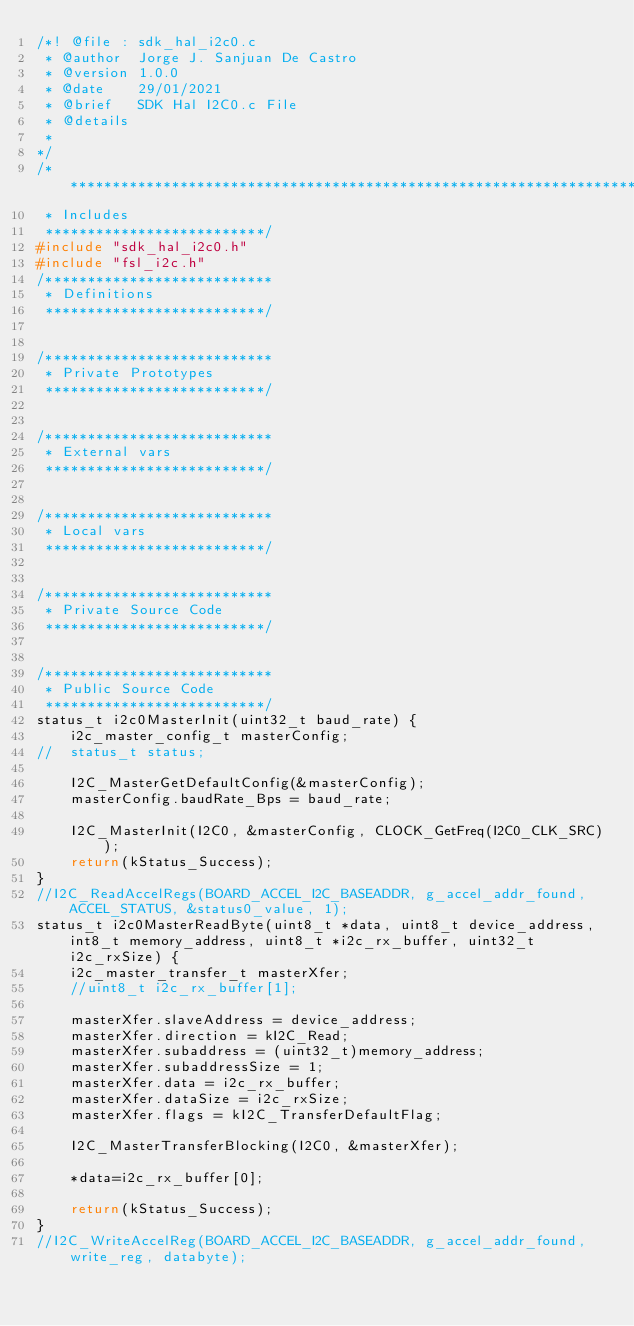<code> <loc_0><loc_0><loc_500><loc_500><_C_>/*! @file : sdk_hal_i2c0.c
 * @author  Jorge J. Sanjuan De Castro
 * @version 1.0.0
 * @date    29/01/2021
 * @brief   SDK Hal I2C0.c File
 * @details
 *
*/
/*******************************************************************************
 * Includes
 **************************/
#include "sdk_hal_i2c0.h"
#include "fsl_i2c.h"
/***************************
 * Definitions
 **************************/


/***************************
 * Private Prototypes
 **************************/


/***************************
 * External vars
 **************************/


/***************************
 * Local vars
 **************************/


/***************************
 * Private Source Code
 **************************/


/***************************
 * Public Source Code
 **************************/
status_t i2c0MasterInit(uint32_t baud_rate) {
	i2c_master_config_t masterConfig;
//	status_t status;

	I2C_MasterGetDefaultConfig(&masterConfig);
    masterConfig.baudRate_Bps = baud_rate;

    I2C_MasterInit(I2C0, &masterConfig, CLOCK_GetFreq(I2C0_CLK_SRC));
	return(kStatus_Success);
}
//I2C_ReadAccelRegs(BOARD_ACCEL_I2C_BASEADDR, g_accel_addr_found, ACCEL_STATUS, &status0_value, 1);
status_t i2c0MasterReadByte(uint8_t *data, uint8_t device_address, int8_t memory_address, uint8_t *i2c_rx_buffer, uint32_t i2c_rxSize) {
	i2c_master_transfer_t masterXfer;
	//uint8_t i2c_rx_buffer[1];

    masterXfer.slaveAddress = device_address;
    masterXfer.direction = kI2C_Read;
    masterXfer.subaddress = (uint32_t)memory_address;
    masterXfer.subaddressSize = 1;
    masterXfer.data = i2c_rx_buffer;
    masterXfer.dataSize = i2c_rxSize;
    masterXfer.flags = kI2C_TransferDefaultFlag;

    I2C_MasterTransferBlocking(I2C0, &masterXfer);

    *data=i2c_rx_buffer[0];

    return(kStatus_Success);
}
//I2C_WriteAccelReg(BOARD_ACCEL_I2C_BASEADDR, g_accel_addr_found, write_reg, databyte);</code> 